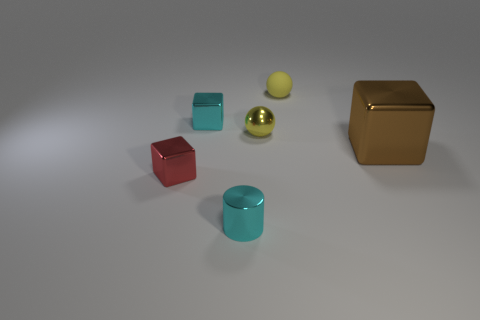Subtract all brown blocks. How many blocks are left? 2 Add 1 matte balls. How many objects exist? 7 Subtract 1 cylinders. How many cylinders are left? 0 Subtract all cylinders. How many objects are left? 5 Subtract all cyan cubes. How many cubes are left? 2 Subtract all purple cubes. Subtract all green cylinders. How many cubes are left? 3 Subtract all cyan metal blocks. Subtract all tiny red metal things. How many objects are left? 4 Add 1 big brown blocks. How many big brown blocks are left? 2 Add 4 cyan cubes. How many cyan cubes exist? 5 Subtract 0 yellow blocks. How many objects are left? 6 